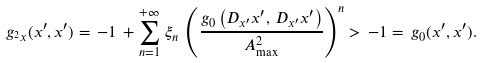<formula> <loc_0><loc_0><loc_500><loc_500>g _ { ^ { 2 } x } ( x ^ { \prime } , x ^ { \prime } ) & = \, - 1 \, + \sum ^ { + \infty } _ { n = 1 } \, \xi _ { n } \, \left ( \frac { g _ { 0 } \left ( D _ { x ^ { \prime } } x ^ { \prime } , \, D _ { x ^ { \prime } } x ^ { \prime } \right ) } { A ^ { 2 } _ { \max } } \right ) ^ { n } > \, - 1 = \, g _ { 0 } ( x ^ { \prime } , x ^ { \prime } ) .</formula> 